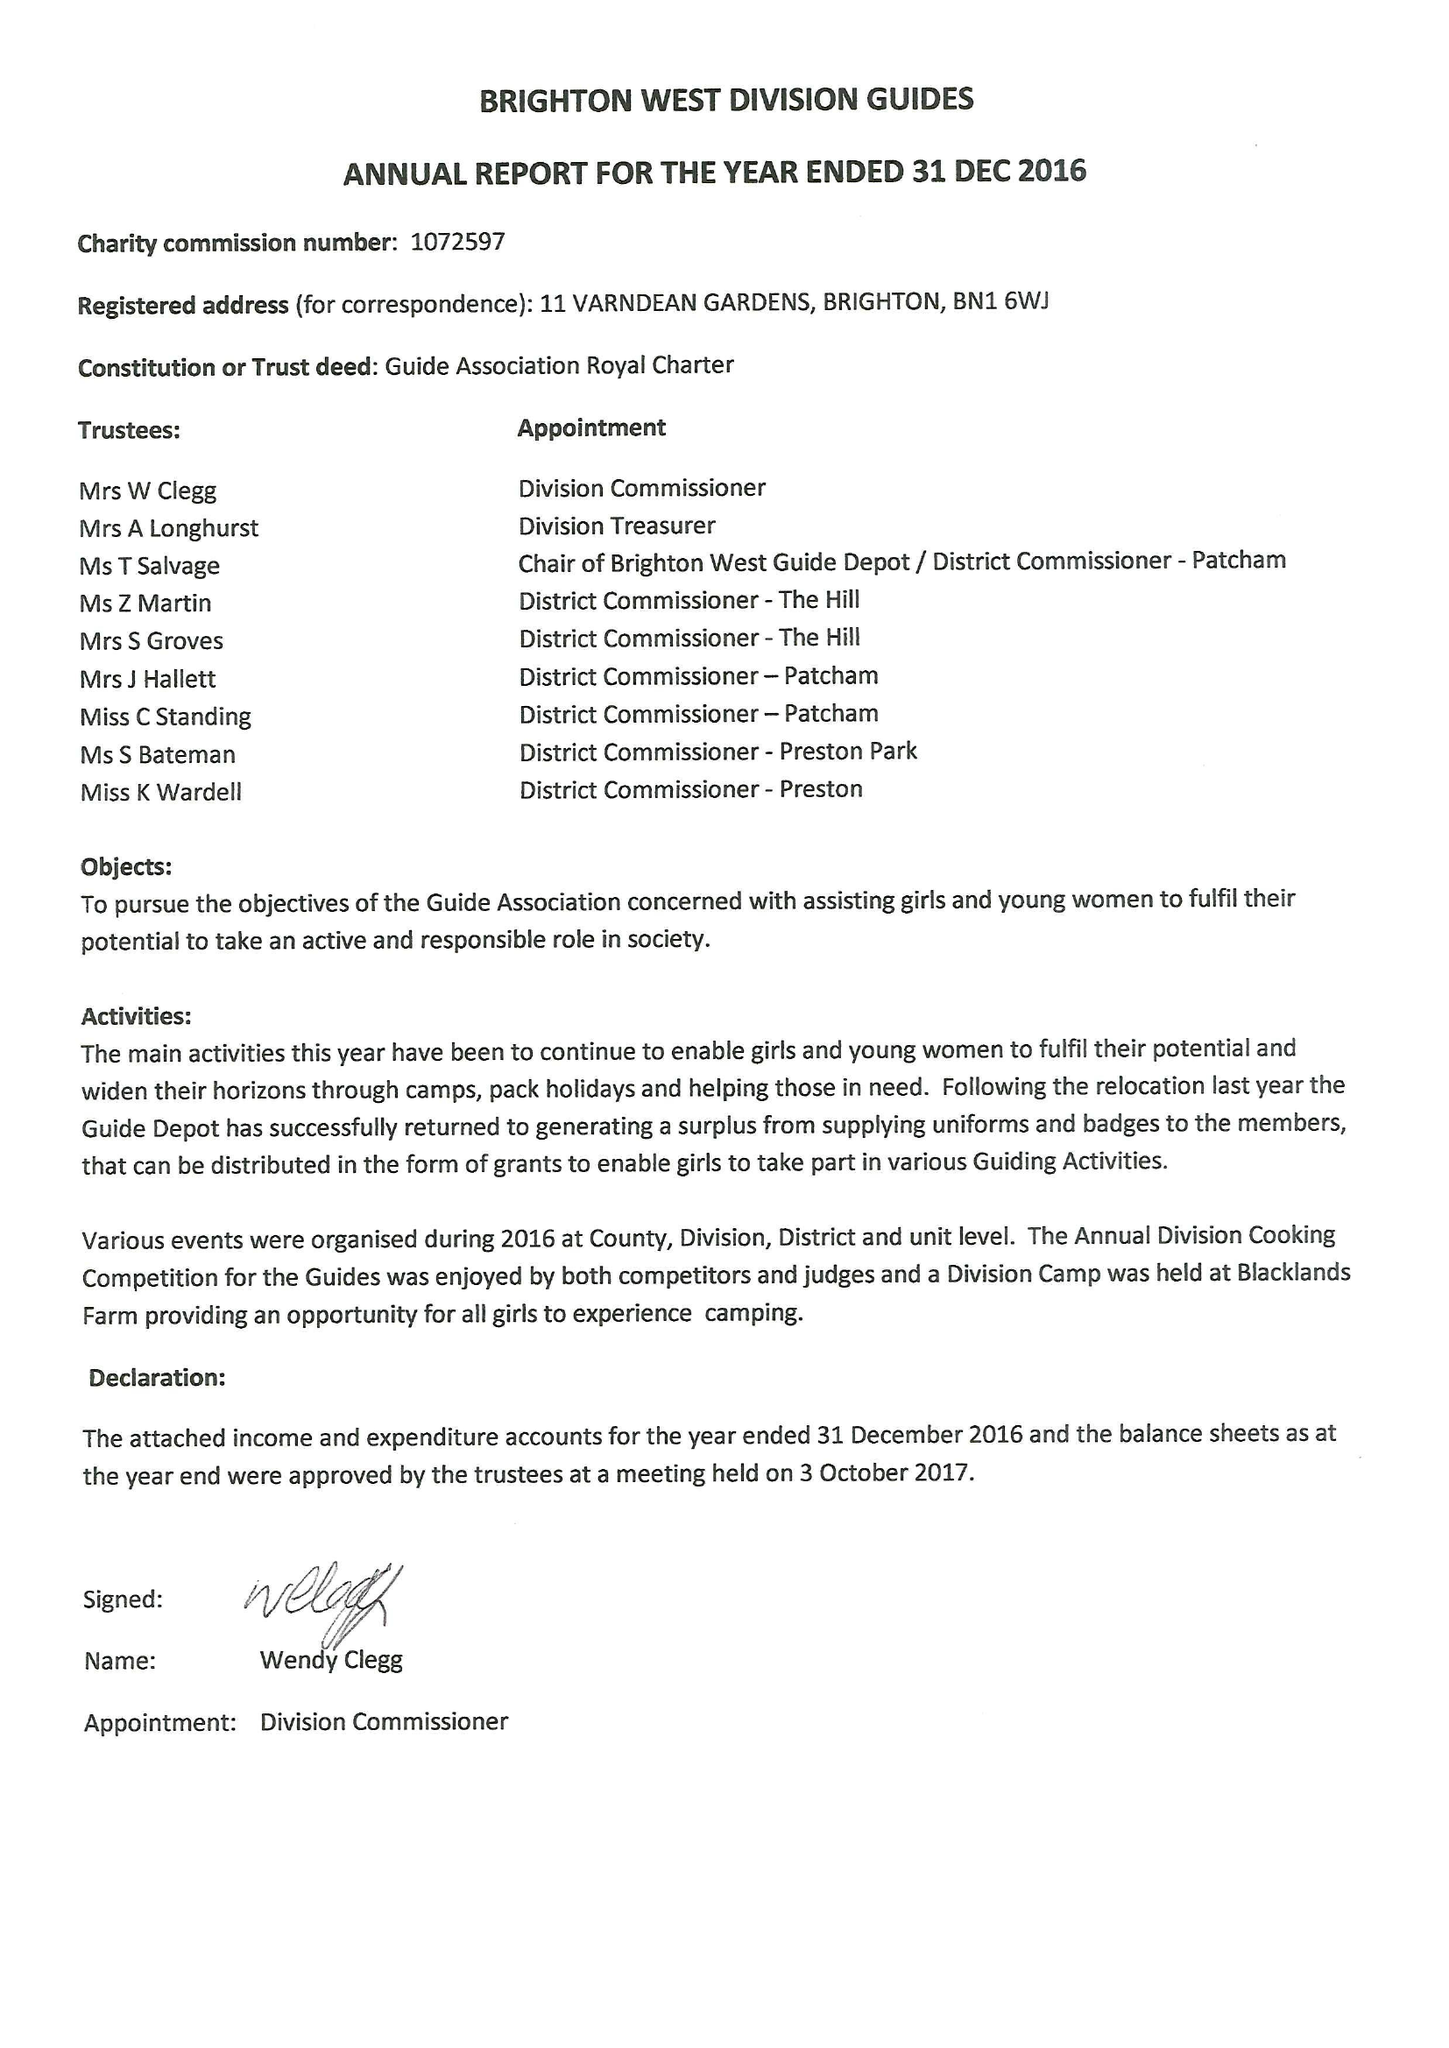What is the value for the address__post_town?
Answer the question using a single word or phrase. BRIGHTON 